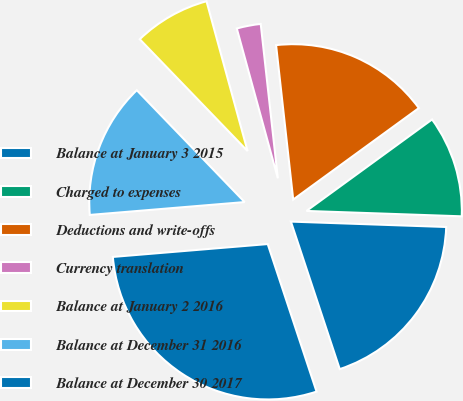Convert chart. <chart><loc_0><loc_0><loc_500><loc_500><pie_chart><fcel>Balance at January 3 2015<fcel>Charged to expenses<fcel>Deductions and write-offs<fcel>Currency translation<fcel>Balance at January 2 2016<fcel>Balance at December 31 2016<fcel>Balance at December 30 2017<nl><fcel>19.36%<fcel>10.57%<fcel>16.74%<fcel>2.5%<fcel>7.95%<fcel>14.11%<fcel>28.77%<nl></chart> 